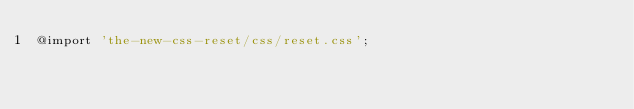<code> <loc_0><loc_0><loc_500><loc_500><_CSS_>@import 'the-new-css-reset/css/reset.css';
</code> 